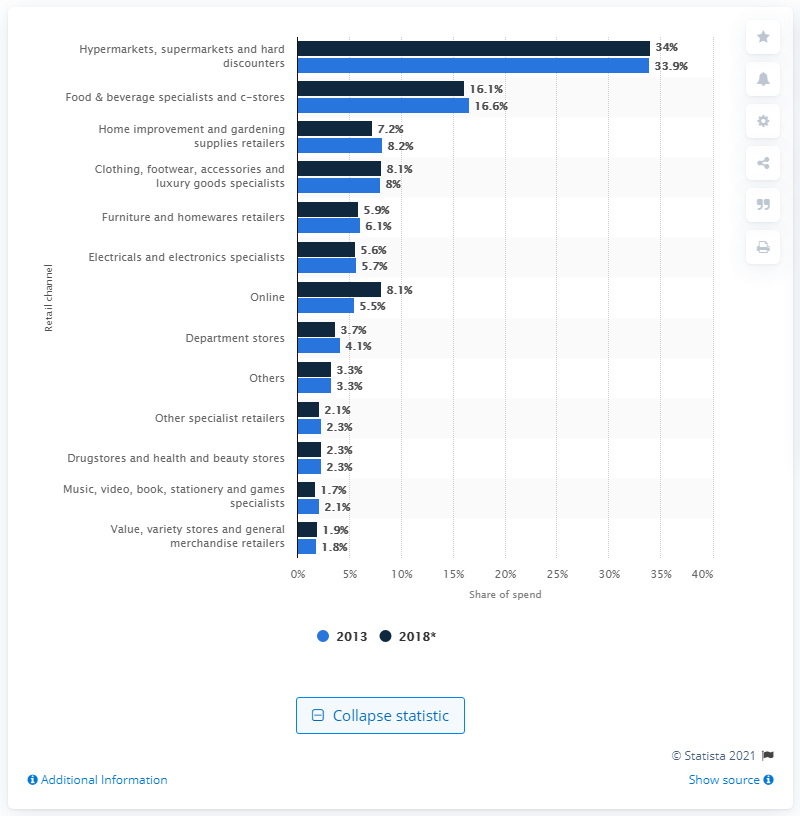Mention a couple of crucial points in this snapshot. In 2013, the online share of spend in Germany was 8.1%. This indicates that a significant portion of the country's overall spending was made through online channels. In 2013, the online share of spend was 5.5%. In 2013, hypermarkets, supermarkets, and hard discounters accounted for 33.9% of total retail spend. The distribution of retail spending in Germany by channel was in 2013. 